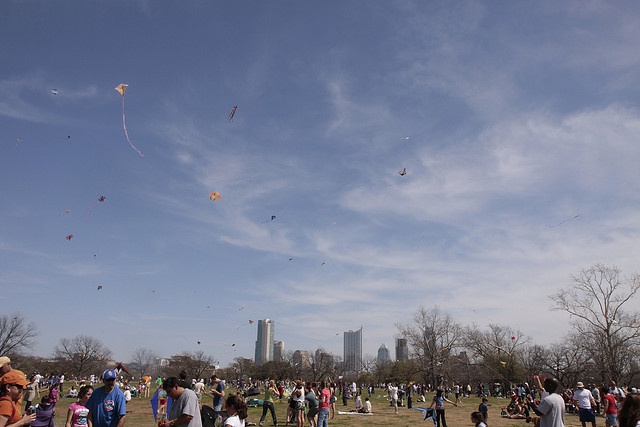Describe the objects in this image and their specific colors. I can see kite in blue, black, gray, darkgray, and maroon tones, people in blue, darkgray, black, and gray tones, people in blue, black, navy, and gray tones, people in blue, black, darkgray, gray, and maroon tones, and people in blue, brown, maroon, and black tones in this image. 